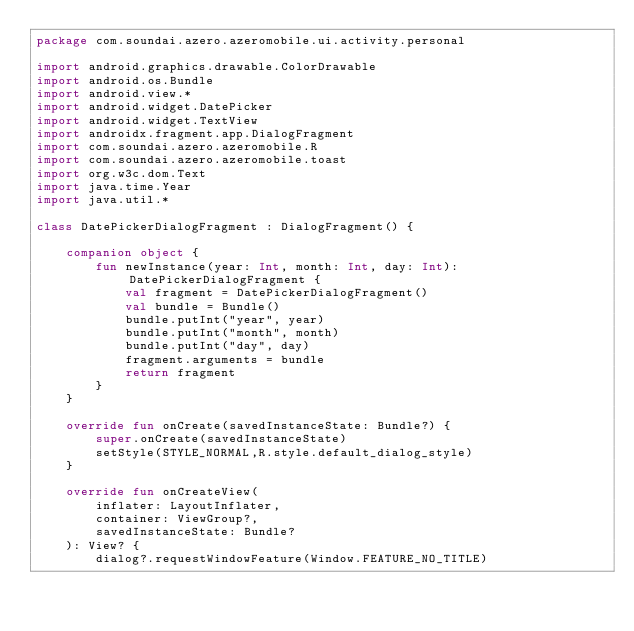Convert code to text. <code><loc_0><loc_0><loc_500><loc_500><_Kotlin_>package com.soundai.azero.azeromobile.ui.activity.personal

import android.graphics.drawable.ColorDrawable
import android.os.Bundle
import android.view.*
import android.widget.DatePicker
import android.widget.TextView
import androidx.fragment.app.DialogFragment
import com.soundai.azero.azeromobile.R
import com.soundai.azero.azeromobile.toast
import org.w3c.dom.Text
import java.time.Year
import java.util.*

class DatePickerDialogFragment : DialogFragment() {

    companion object {
        fun newInstance(year: Int, month: Int, day: Int): DatePickerDialogFragment {
            val fragment = DatePickerDialogFragment()
            val bundle = Bundle()
            bundle.putInt("year", year)
            bundle.putInt("month", month)
            bundle.putInt("day", day)
            fragment.arguments = bundle
            return fragment
        }
    }

    override fun onCreate(savedInstanceState: Bundle?) {
        super.onCreate(savedInstanceState)
        setStyle(STYLE_NORMAL,R.style.default_dialog_style)
    }

    override fun onCreateView(
        inflater: LayoutInflater,
        container: ViewGroup?,
        savedInstanceState: Bundle?
    ): View? {
        dialog?.requestWindowFeature(Window.FEATURE_NO_TITLE)</code> 